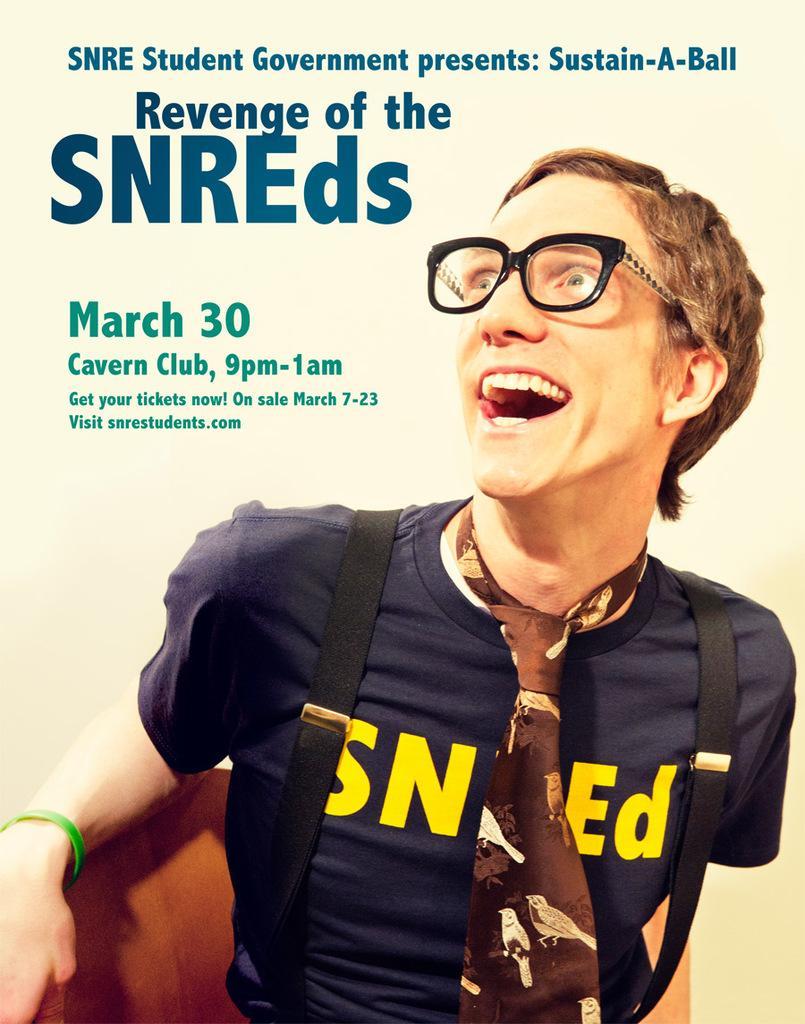In one or two sentences, can you explain what this image depicts? In the image we can see a person wearing clothes, tie, handbag and goggles, and he is carrying a bag on his back. This is a printed text. 